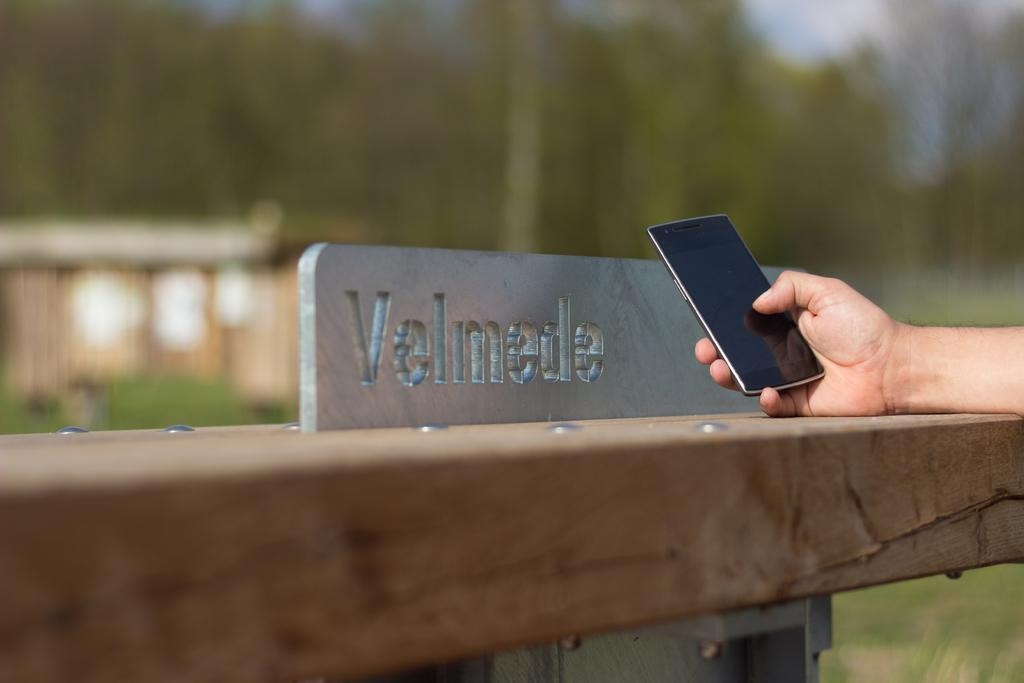What is the main subject of the image? The main subject of the image is a human hand. What is the hand holding in the image? The hand is holding a mobile phone. What can be seen in the background of the image? There are trees in the background of the image. What type of tramp can be seen jumping in the image? There is no tramp present in the image; it features a human hand holding a mobile phone with trees in the background. Is there a volcano visible in the image? No, there is no volcano present in the image. 